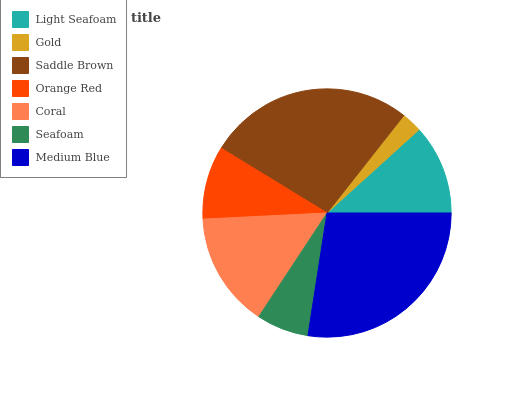Is Gold the minimum?
Answer yes or no. Yes. Is Medium Blue the maximum?
Answer yes or no. Yes. Is Saddle Brown the minimum?
Answer yes or no. No. Is Saddle Brown the maximum?
Answer yes or no. No. Is Saddle Brown greater than Gold?
Answer yes or no. Yes. Is Gold less than Saddle Brown?
Answer yes or no. Yes. Is Gold greater than Saddle Brown?
Answer yes or no. No. Is Saddle Brown less than Gold?
Answer yes or no. No. Is Light Seafoam the high median?
Answer yes or no. Yes. Is Light Seafoam the low median?
Answer yes or no. Yes. Is Orange Red the high median?
Answer yes or no. No. Is Coral the low median?
Answer yes or no. No. 